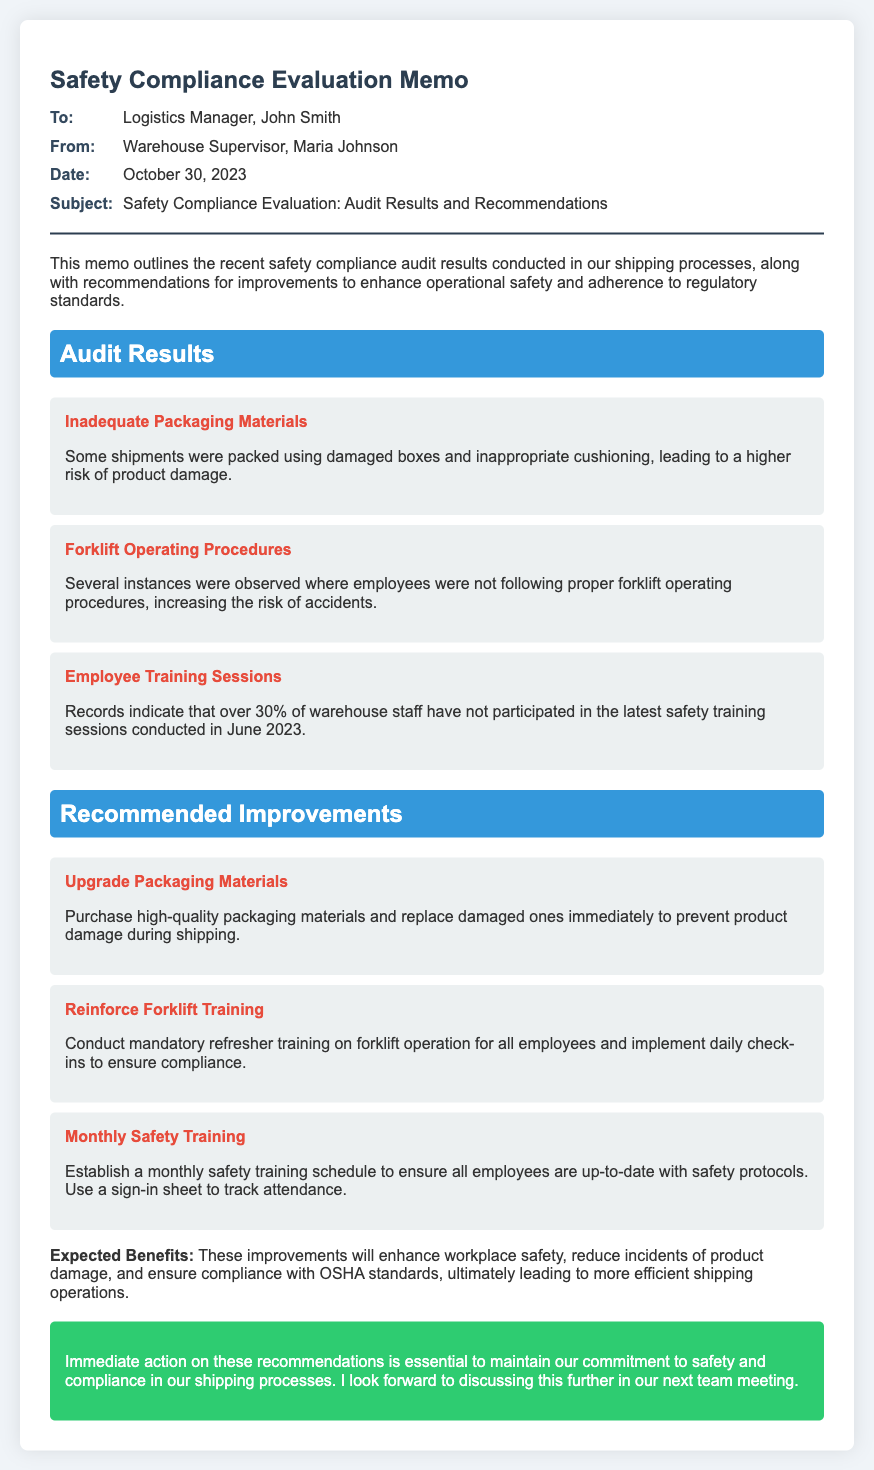what is the date of the memo? The date of the memo is specifically stated in the document under the memo info section.
Answer: October 30, 2023 who is the memo addressed to? The recipient of the memo is mentioned in the "To" section provided in the memo.
Answer: Logistics Manager, John Smith how many findings are listed in the audit results? The document lists three specific findings under the audit results section.
Answer: 3 what is the recommended improvement related to employee training? The recommendations section includes a specific suggestion regarding employee training sessions.
Answer: Monthly Safety Training what is one expected benefit of the recommended improvements? The document outlines benefits related to the implementation of the recommendations, indicating improvements in overall safety and compliance.
Answer: Enhance workplace safety 